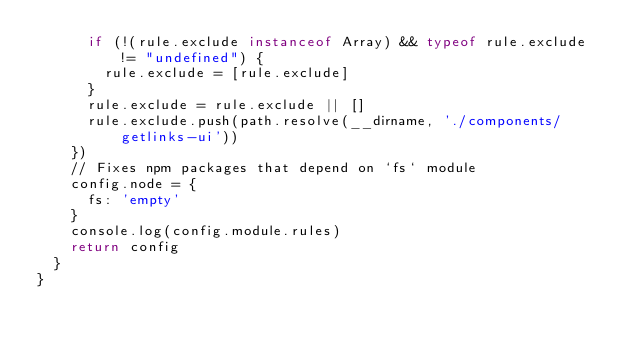<code> <loc_0><loc_0><loc_500><loc_500><_JavaScript_>      if (!(rule.exclude instanceof Array) && typeof rule.exclude != "undefined") {
        rule.exclude = [rule.exclude]
      }
      rule.exclude = rule.exclude || []
      rule.exclude.push(path.resolve(__dirname, './components/getlinks-ui'))
    })
    // Fixes npm packages that depend on `fs` module
    config.node = {
      fs: 'empty'
    }
    console.log(config.module.rules)
    return config
  }
}
</code> 